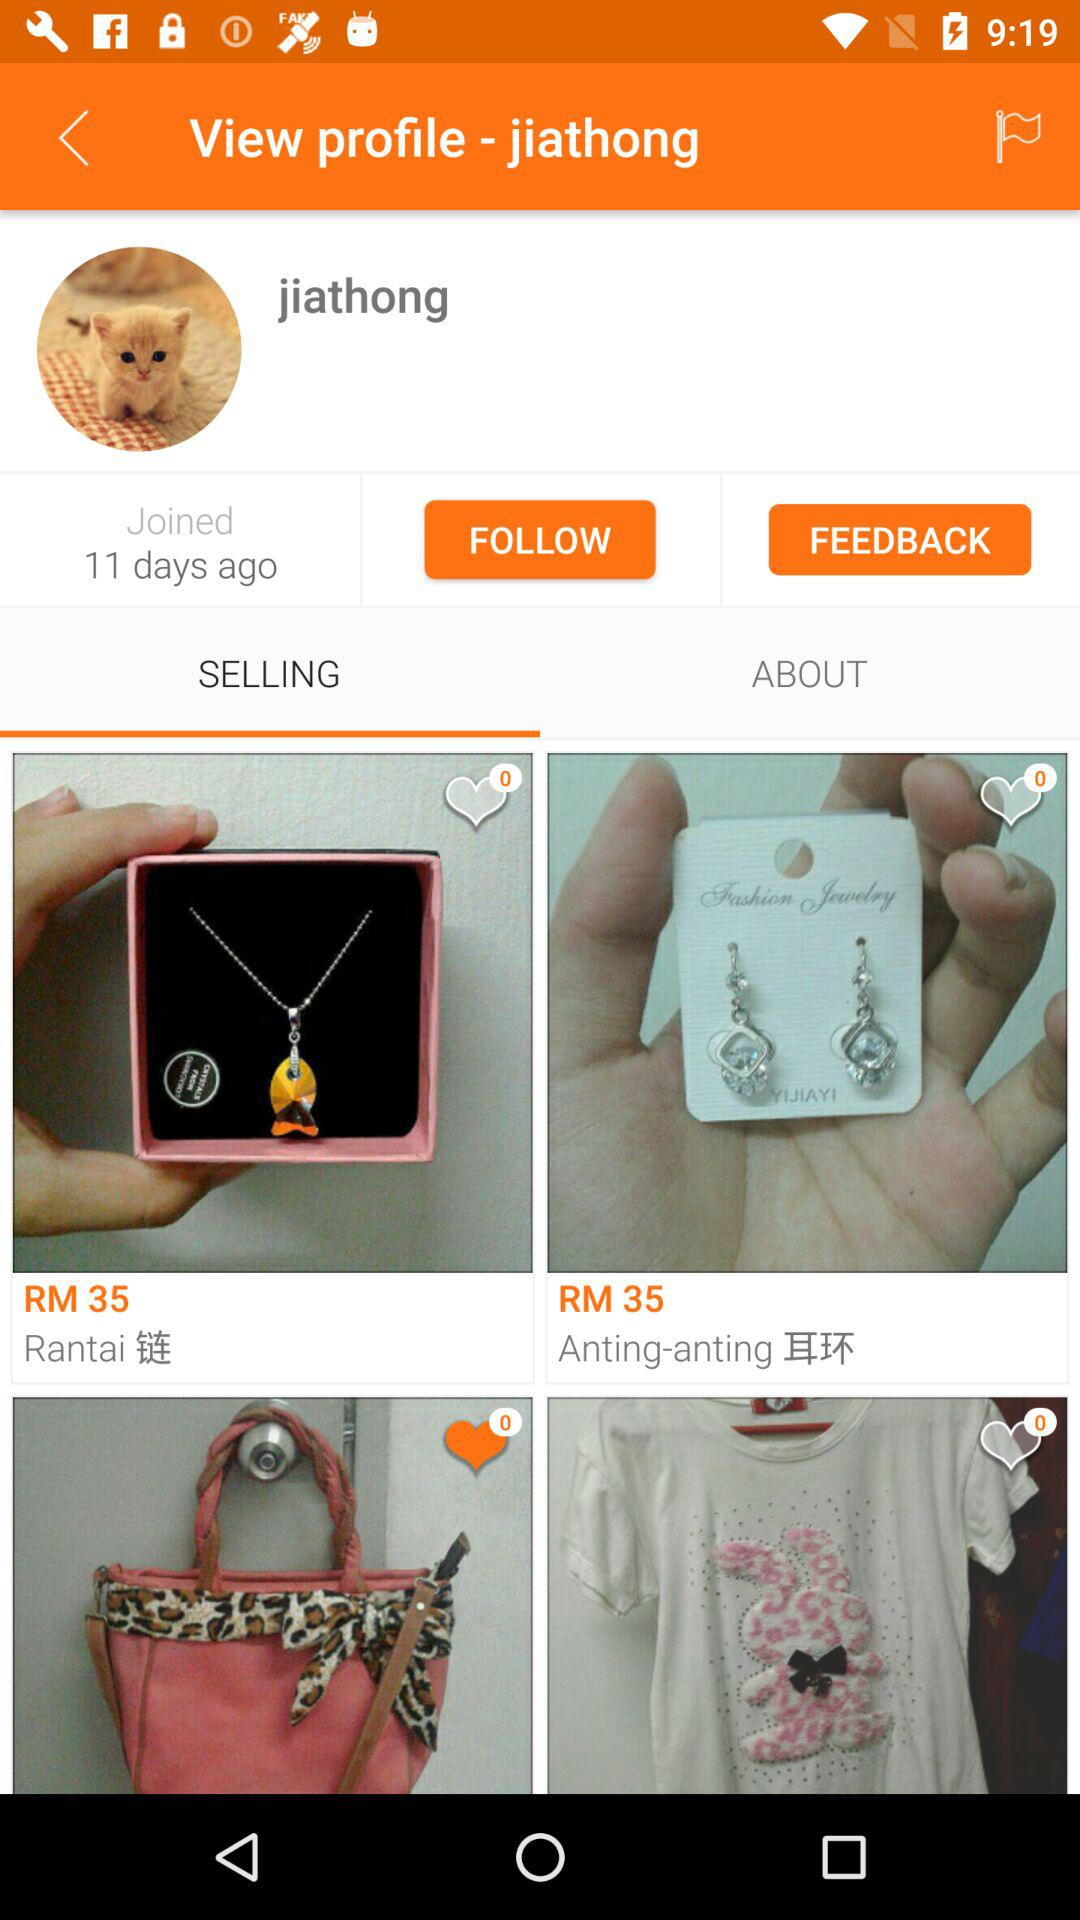How many days ago did the user join? The user joined 11 days ago. 